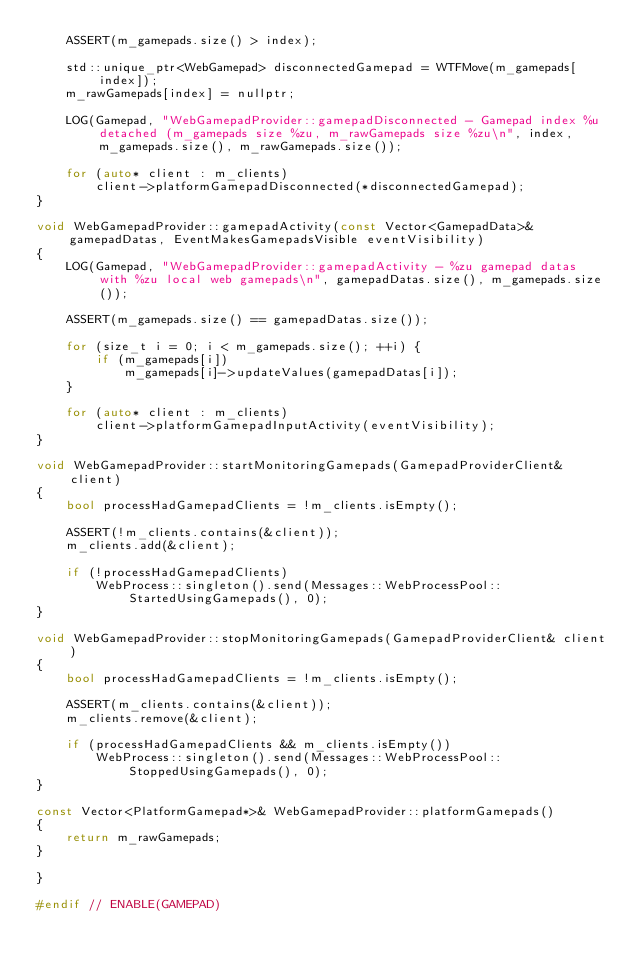Convert code to text. <code><loc_0><loc_0><loc_500><loc_500><_C++_>    ASSERT(m_gamepads.size() > index);

    std::unique_ptr<WebGamepad> disconnectedGamepad = WTFMove(m_gamepads[index]);
    m_rawGamepads[index] = nullptr;

    LOG(Gamepad, "WebGamepadProvider::gamepadDisconnected - Gamepad index %u detached (m_gamepads size %zu, m_rawGamepads size %zu\n", index, m_gamepads.size(), m_rawGamepads.size());

    for (auto* client : m_clients)
        client->platformGamepadDisconnected(*disconnectedGamepad);
}

void WebGamepadProvider::gamepadActivity(const Vector<GamepadData>& gamepadDatas, EventMakesGamepadsVisible eventVisibility)
{
    LOG(Gamepad, "WebGamepadProvider::gamepadActivity - %zu gamepad datas with %zu local web gamepads\n", gamepadDatas.size(), m_gamepads.size());

    ASSERT(m_gamepads.size() == gamepadDatas.size());

    for (size_t i = 0; i < m_gamepads.size(); ++i) {
        if (m_gamepads[i])
            m_gamepads[i]->updateValues(gamepadDatas[i]);
    }

    for (auto* client : m_clients)
        client->platformGamepadInputActivity(eventVisibility);
}

void WebGamepadProvider::startMonitoringGamepads(GamepadProviderClient& client)
{
    bool processHadGamepadClients = !m_clients.isEmpty();

    ASSERT(!m_clients.contains(&client));
    m_clients.add(&client);

    if (!processHadGamepadClients)
        WebProcess::singleton().send(Messages::WebProcessPool::StartedUsingGamepads(), 0);
}

void WebGamepadProvider::stopMonitoringGamepads(GamepadProviderClient& client)
{
    bool processHadGamepadClients = !m_clients.isEmpty();

    ASSERT(m_clients.contains(&client));
    m_clients.remove(&client);

    if (processHadGamepadClients && m_clients.isEmpty())
        WebProcess::singleton().send(Messages::WebProcessPool::StoppedUsingGamepads(), 0);
}

const Vector<PlatformGamepad*>& WebGamepadProvider::platformGamepads()
{
    return m_rawGamepads;
}

}

#endif // ENABLE(GAMEPAD)
</code> 